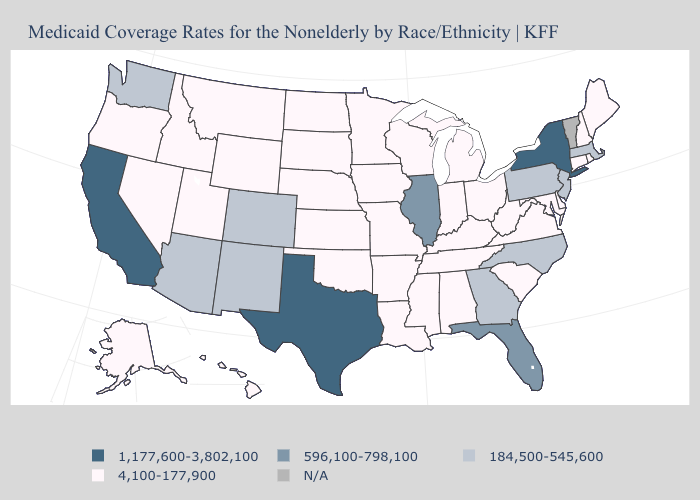Name the states that have a value in the range 4,100-177,900?
Answer briefly. Alabama, Alaska, Arkansas, Connecticut, Delaware, Hawaii, Idaho, Indiana, Iowa, Kansas, Kentucky, Louisiana, Maine, Maryland, Michigan, Minnesota, Mississippi, Missouri, Montana, Nebraska, Nevada, New Hampshire, North Dakota, Ohio, Oklahoma, Oregon, Rhode Island, South Carolina, South Dakota, Tennessee, Utah, Virginia, West Virginia, Wisconsin, Wyoming. Among the states that border Nevada , does Idaho have the highest value?
Give a very brief answer. No. What is the highest value in states that border Pennsylvania?
Give a very brief answer. 1,177,600-3,802,100. Does Mississippi have the lowest value in the USA?
Short answer required. Yes. Does Florida have the lowest value in the USA?
Concise answer only. No. Which states have the lowest value in the MidWest?
Be succinct. Indiana, Iowa, Kansas, Michigan, Minnesota, Missouri, Nebraska, North Dakota, Ohio, South Dakota, Wisconsin. What is the highest value in the Northeast ?
Keep it brief. 1,177,600-3,802,100. Does New York have the lowest value in the USA?
Quick response, please. No. What is the highest value in the West ?
Be succinct. 1,177,600-3,802,100. Does the first symbol in the legend represent the smallest category?
Answer briefly. No. Name the states that have a value in the range 1,177,600-3,802,100?
Concise answer only. California, New York, Texas. Does New York have the highest value in the USA?
Give a very brief answer. Yes. Name the states that have a value in the range 184,500-545,600?
Short answer required. Arizona, Colorado, Georgia, Massachusetts, New Jersey, New Mexico, North Carolina, Pennsylvania, Washington. What is the highest value in the USA?
Concise answer only. 1,177,600-3,802,100. 